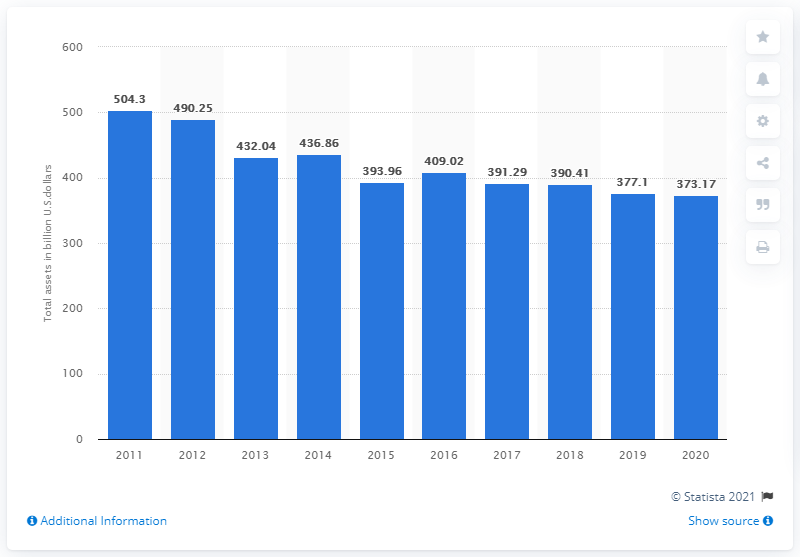Outline some significant characteristics in this image. In 2020, the total assets of HSBC in North America were 373.17. In 2019, the assets of HSBC in North America were valued at 377.1. 